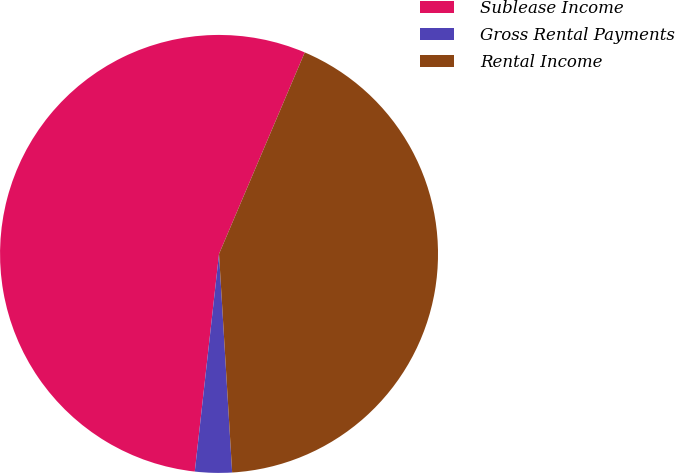Convert chart to OTSL. <chart><loc_0><loc_0><loc_500><loc_500><pie_chart><fcel>Sublease Income<fcel>Gross Rental Payments<fcel>Rental Income<nl><fcel>54.63%<fcel>2.72%<fcel>42.64%<nl></chart> 